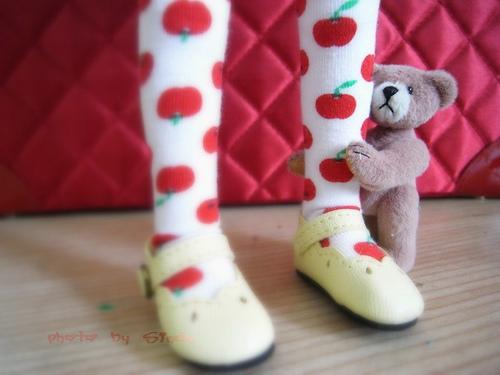Does the bear what to be picked up?
Write a very short answer. Yes. What color are the socks?
Quick response, please. Red and white. What color are the shoes?
Answer briefly. Yellow. What's the design on the socks?
Write a very short answer. Apples. 